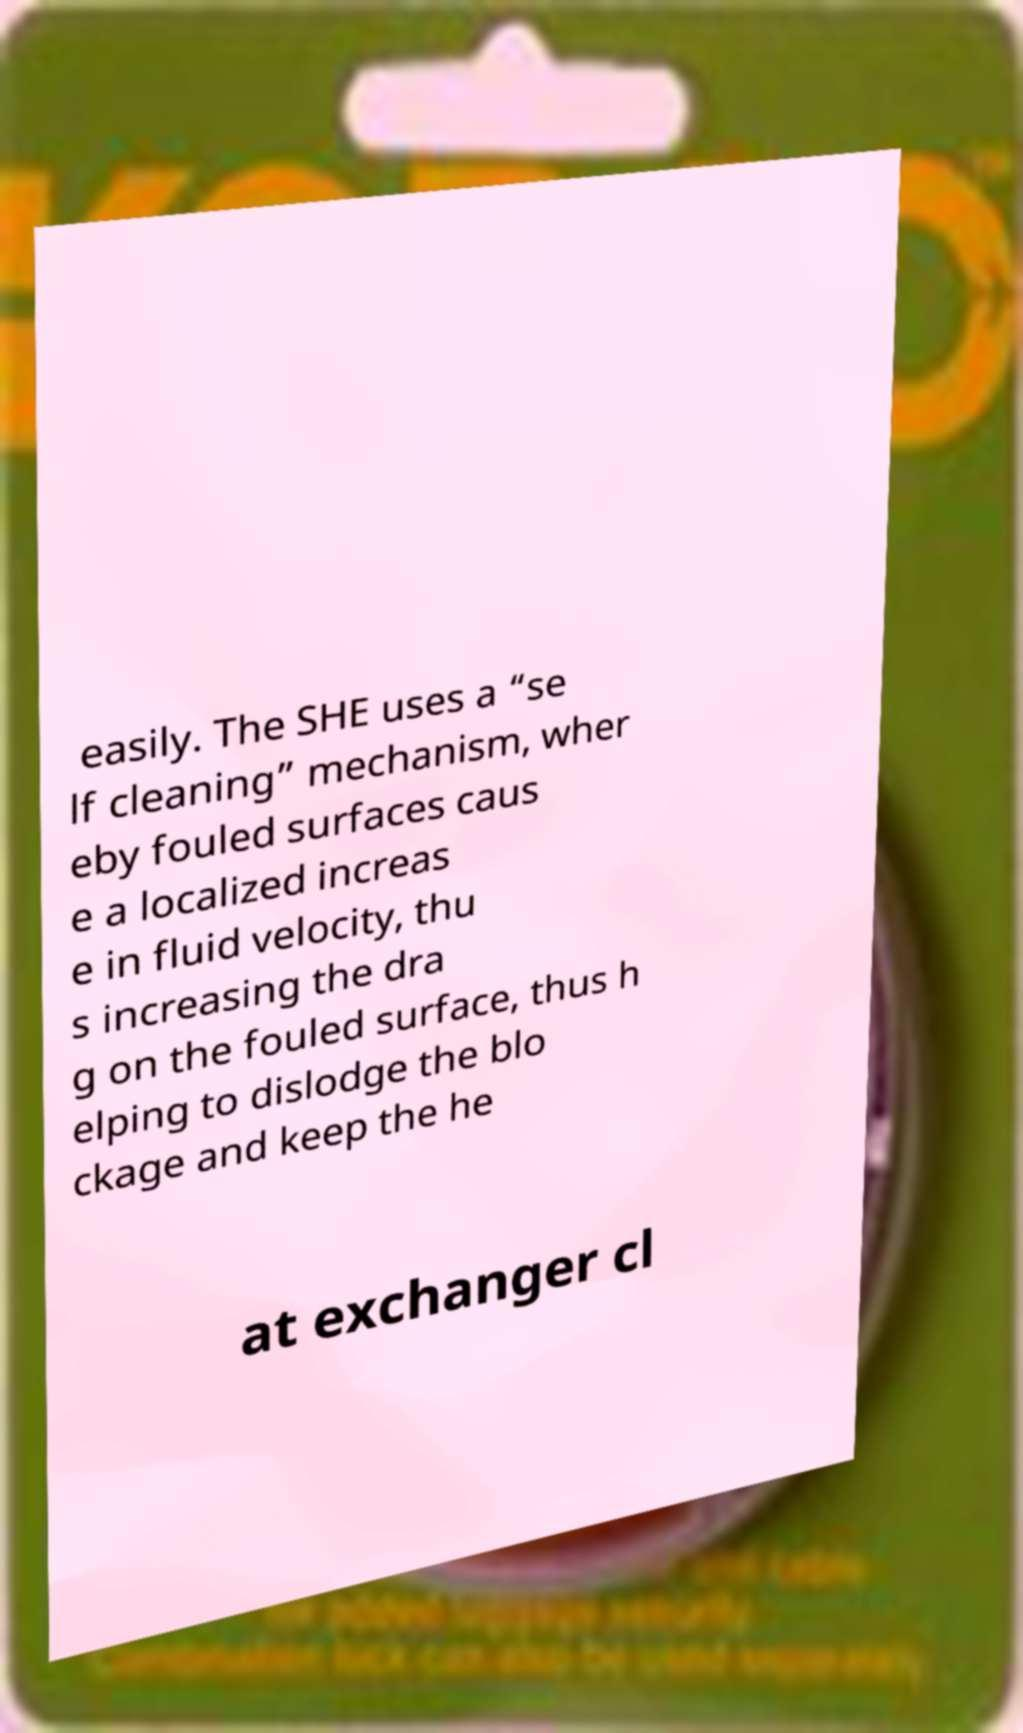Please identify and transcribe the text found in this image. easily. The SHE uses a “se lf cleaning” mechanism, wher eby fouled surfaces caus e a localized increas e in fluid velocity, thu s increasing the dra g on the fouled surface, thus h elping to dislodge the blo ckage and keep the he at exchanger cl 